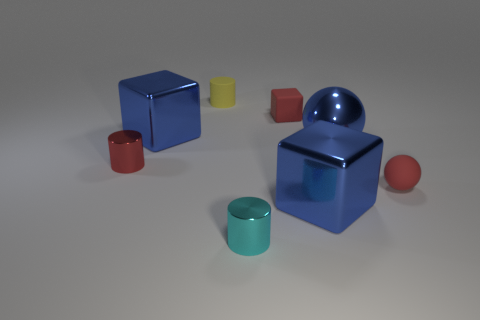What time of day do you think it is based on the lighting in the image? The shadows in the image are soft and diffuse, suggesting that the lighting doesn't come from a natural source like the sun. It is more likely studio lighting used to create an evenly lit scene, so it's difficult to determine the time of day from this image. 